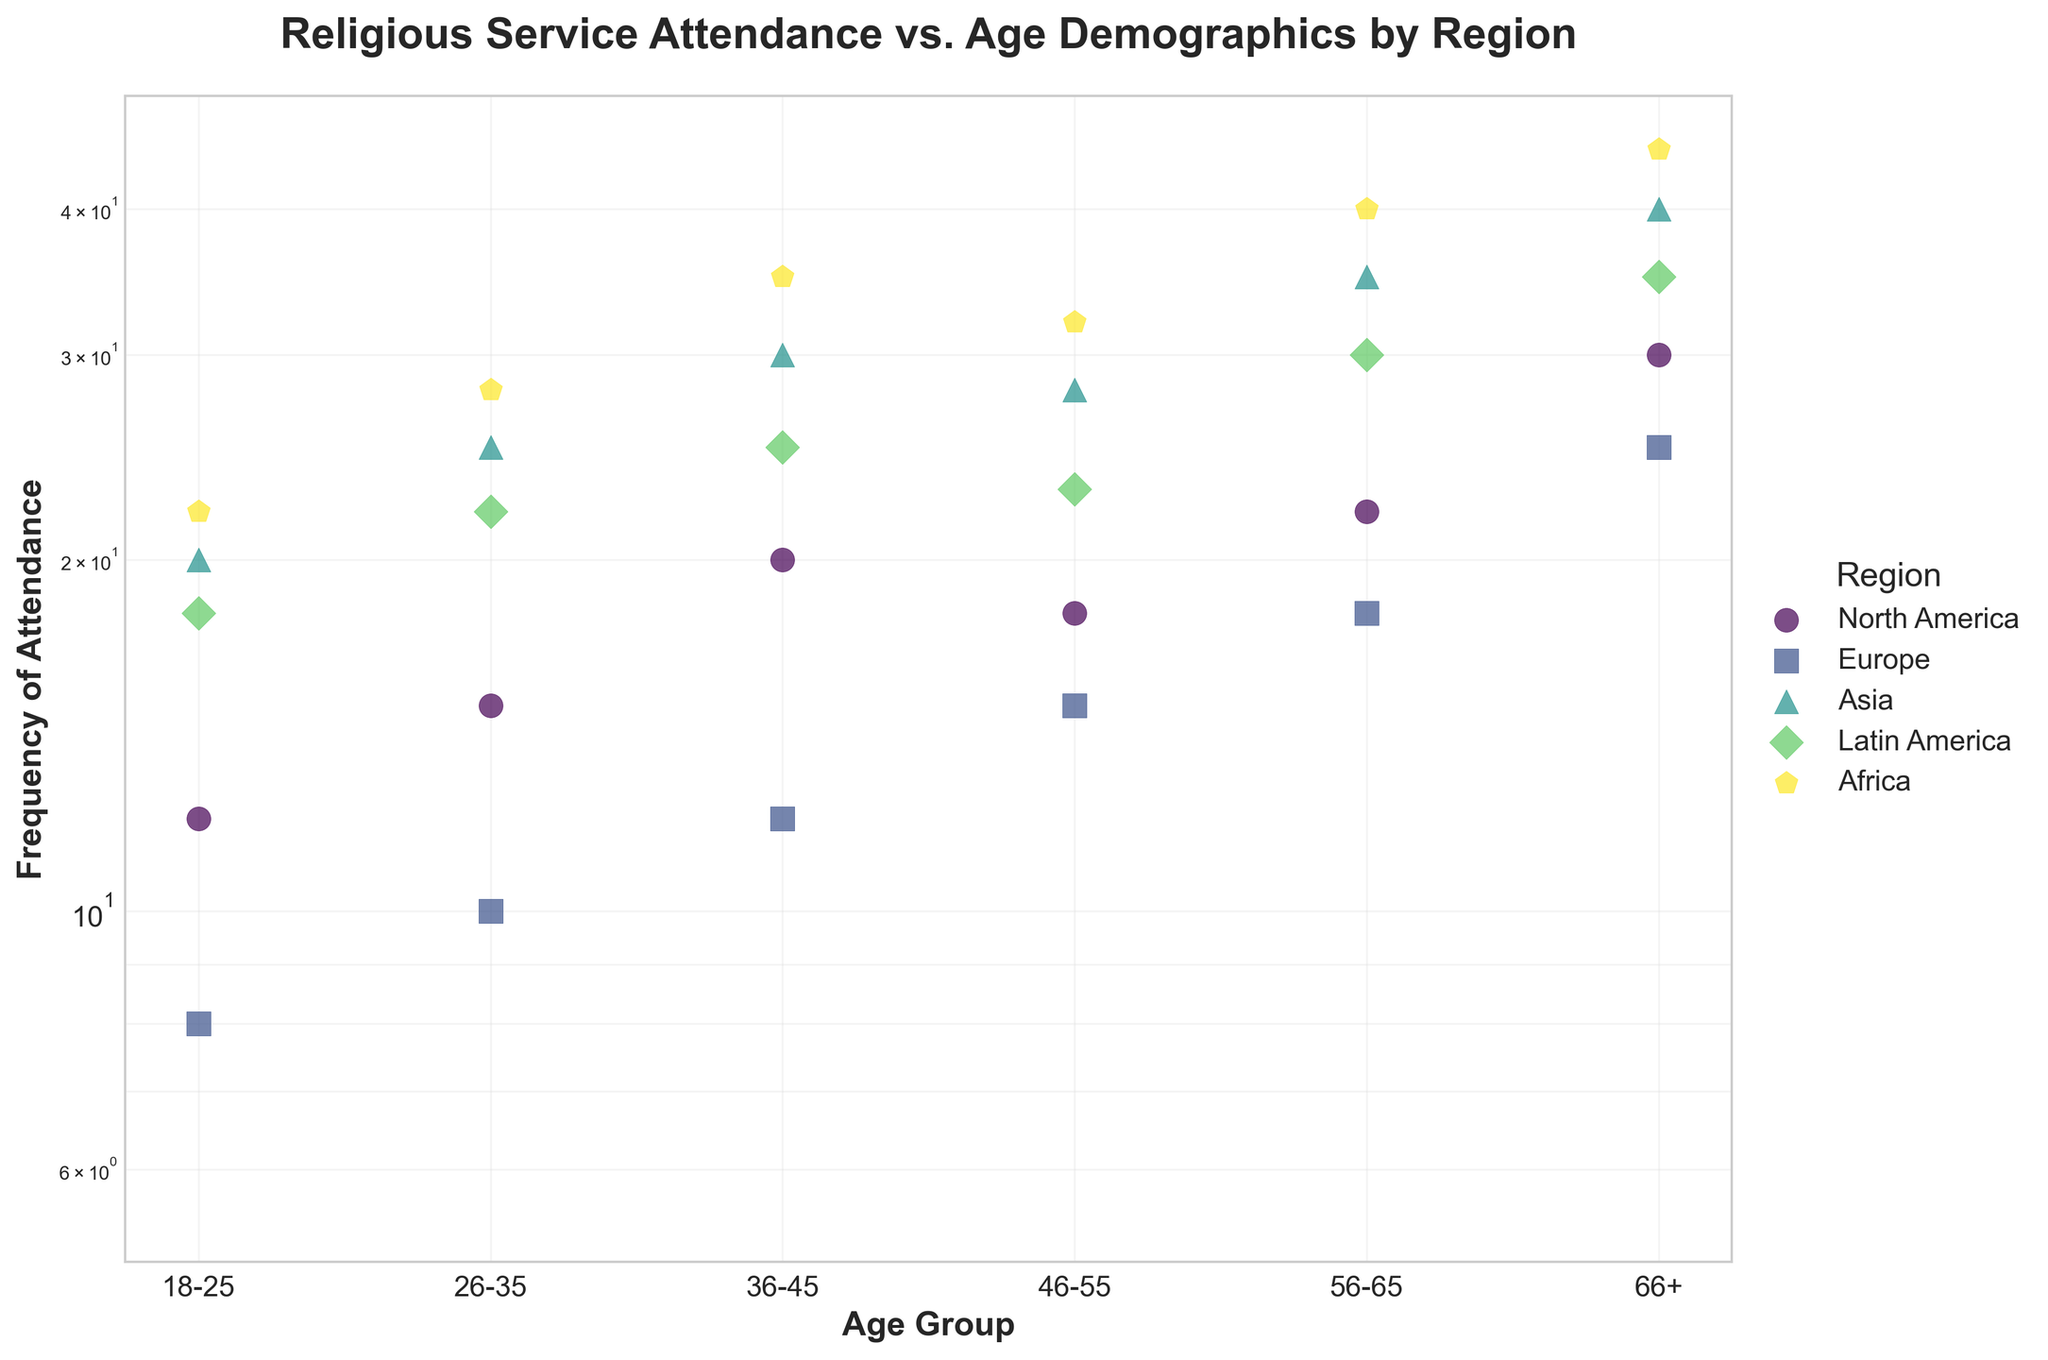How is the frequency of religious service attendance distributed across different age groups in North America? The scatter plot shows the frequency of religious service attendance for the age groups 18-25, 26-35, 36-45, 46-55, 56-65, and 66+ within North America. Attendance increases from 12 for the 18-25 age group to 30 for the 66+ age group with some fluctuations.
Answer: Increasing with age Which region has the highest frequency of attendance for age group 66+? From the scatter plot, the highest frequency value for the 66+ age group is in Africa, with a value of 45, which is higher than other regions.
Answer: Africa How does the frequency of attendance for age group 26-35 in Europe compare to North America? The 26-35 age group in Europe has a frequency of 10, while in North America, the frequency is 15. Therefore, Europe has a lower frequency compared to North America for this age group.
Answer: Lower Which age group in Asia shows the highest frequency of religious service attendance? By looking at the scatter plot, the 66+ age group in Asia shows the highest frequency of attendance, with a value of 40.
Answer: 66+ What is the range of the frequency of attendance values for the region of Latin America? The frequency values for Latin America in ascending order are: 18, 22, 25, 23, 30, 35. The range is the difference between the highest and lowest values, i.e., 35 - 18 = 17.
Answer: 17 What general trend can you observe in the frequency of religious service attendance as age increases across most regions? Most regions show an increase in the frequency of religious service attendance as the age increases. This is evident from the ascending values across the age groups within each region.
Answer: Increasing trend Are there any regions where the attendance frequency for younger age groups (18-25) is relatively higher compared to other regions? Yes, in Africa and Asia, the 18-25 age group shows relatively higher attendance frequencies of 22 and 20 respectively, compared to lower values in North America, Europe, and Latin America.
Answer: Africa and Asia Identify the region with the steepest increase in frequency from the 56-65 to the 66+ age group. Asia shows an increase from 35 to 40, North America from 22 to 30, Europe from 18 to 25, Latin America from 30 to 35, and Africa from 40 to 45. The steepness is consistent across multiple steps, but North America shows the largest single-step increase from 22 to 30.
Answer: North America What is the minimum frequency of religious attendance across all regions and age groups? Looking at the plot, the minimum frequency of religious attendance is in Europe for the 18-25 age group, with a value of 8.
Answer: 8 